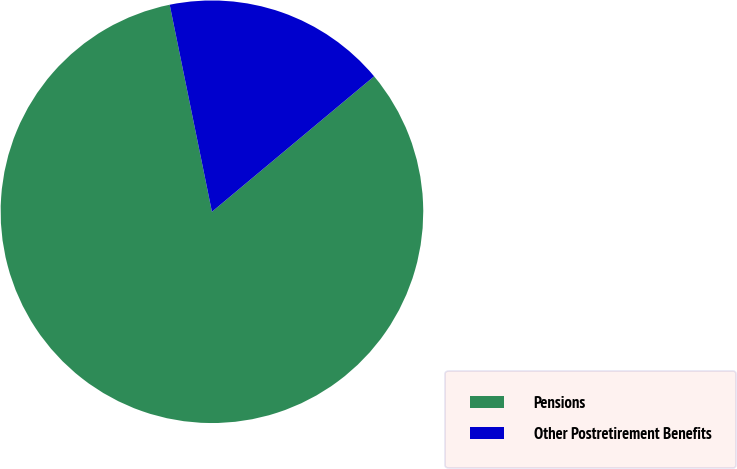<chart> <loc_0><loc_0><loc_500><loc_500><pie_chart><fcel>Pensions<fcel>Other Postretirement Benefits<nl><fcel>82.87%<fcel>17.13%<nl></chart> 